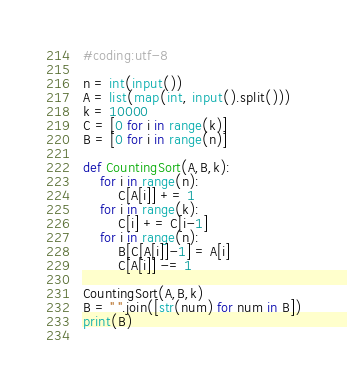Convert code to text. <code><loc_0><loc_0><loc_500><loc_500><_Python_>#coding:utf-8

n = int(input())
A = list(map(int, input().split()))
k = 10000
C = [0 for i in range(k)]
B = [0 for i in range(n)]

def CountingSort(A,B,k):
    for i in range(n):
        C[A[i]] += 1
    for i in range(k):
        C[i] += C[i-1]
    for i in range(n):
        B[C[A[i]]-1] = A[i]
        C[A[i]] -= 1

CountingSort(A,B,k)
B = " ".join([str(num) for num in B])
print(B)
        
</code> 